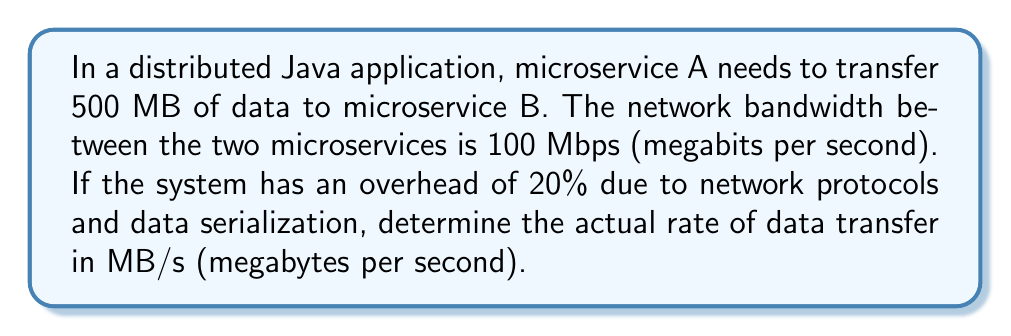Teach me how to tackle this problem. Let's solve this problem step by step:

1. Convert the bandwidth from Mbps to MB/s:
   $$ 100 \text{ Mbps} = 100 \div 8 \text{ MB/s} = 12.5 \text{ MB/s} $$

2. Calculate the effective bandwidth considering the 20% overhead:
   $$ \text{Effective Bandwidth} = 12.5 \text{ MB/s} \times (1 - 0.2) = 12.5 \times 0.8 = 10 \text{ MB/s} $$

3. The actual rate of data transfer is the effective bandwidth:
   $$ \text{Actual Rate} = 10 \text{ MB/s} $$

This rate represents the speed at which useful data (excluding overhead) can be transferred between microservices A and B in the distributed Java application.
Answer: 10 MB/s 